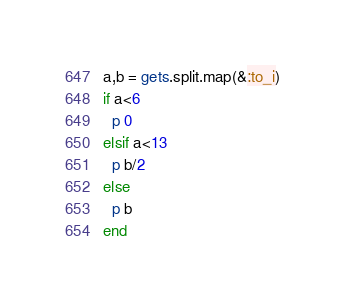<code> <loc_0><loc_0><loc_500><loc_500><_Ruby_>a,b = gets.split.map(&:to_i)
if a<6
  p 0
elsif a<13
  p b/2
else
  p b
end</code> 